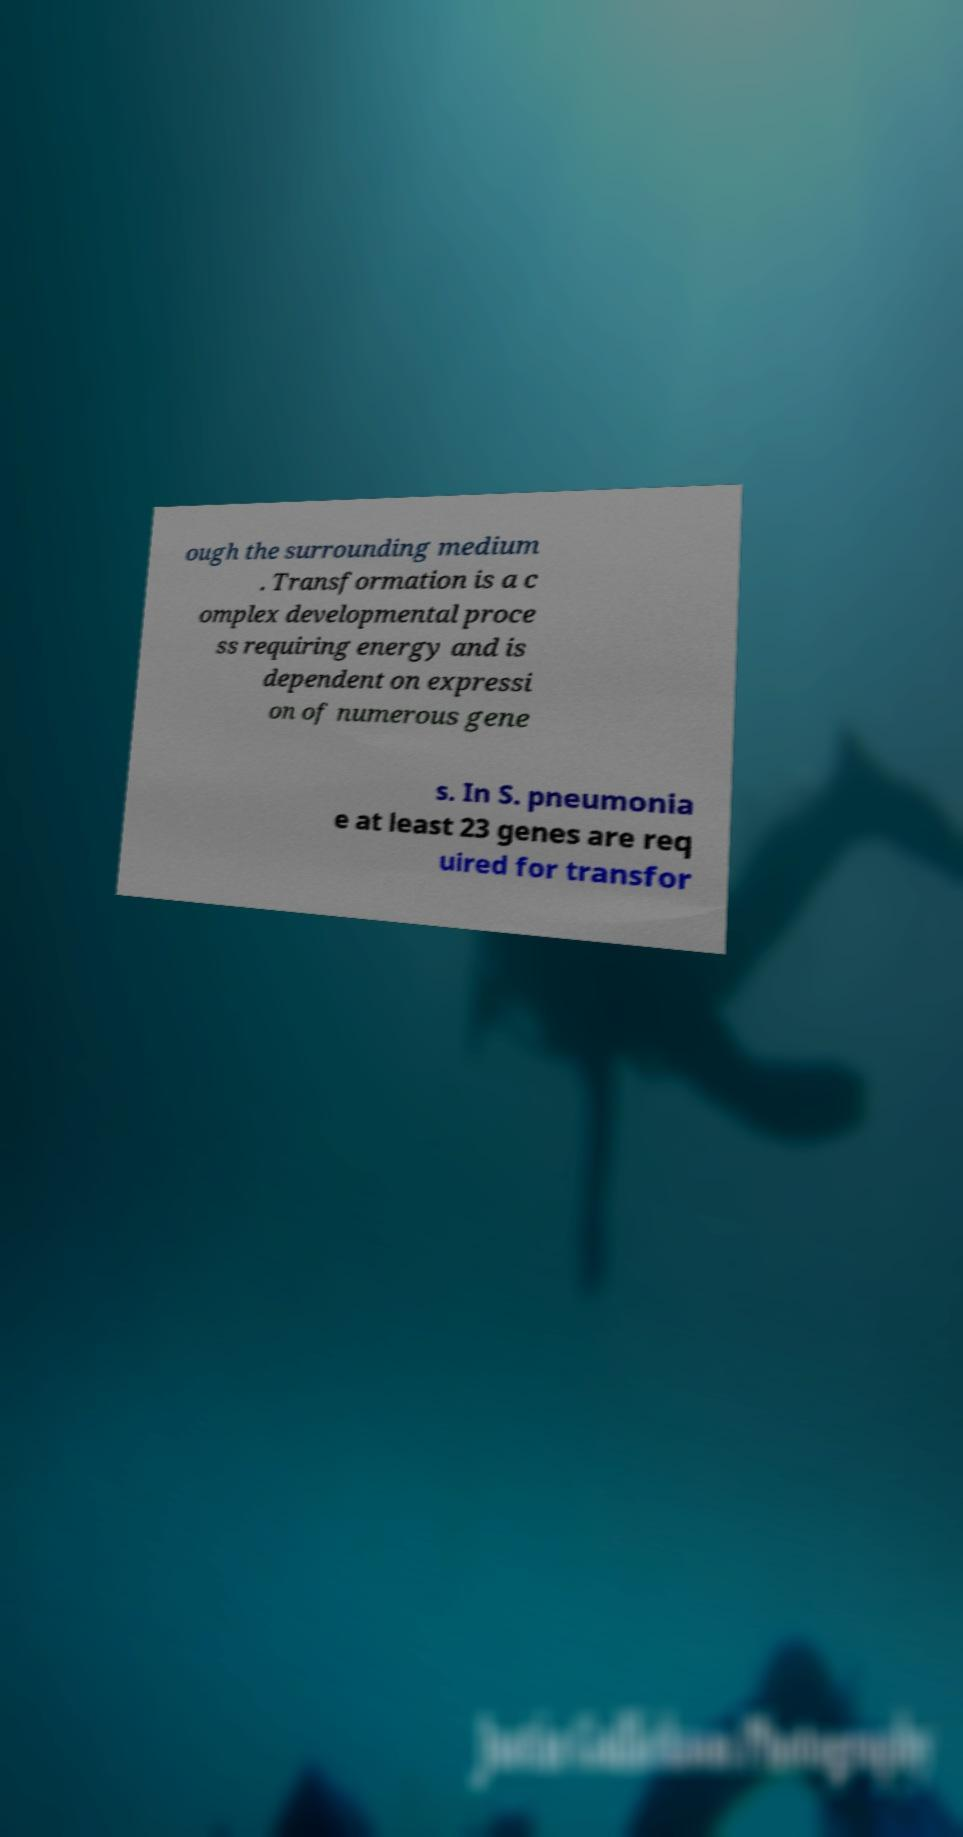There's text embedded in this image that I need extracted. Can you transcribe it verbatim? ough the surrounding medium . Transformation is a c omplex developmental proce ss requiring energy and is dependent on expressi on of numerous gene s. In S. pneumonia e at least 23 genes are req uired for transfor 